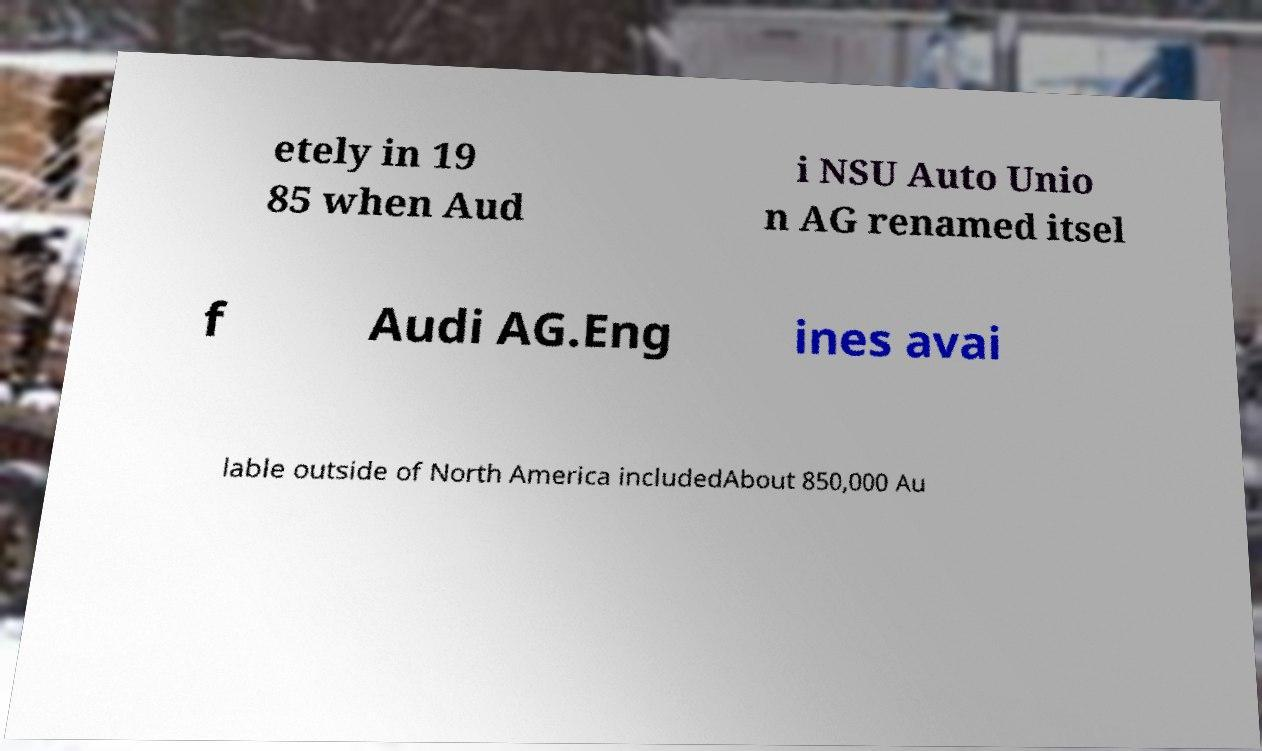I need the written content from this picture converted into text. Can you do that? etely in 19 85 when Aud i NSU Auto Unio n AG renamed itsel f Audi AG.Eng ines avai lable outside of North America includedAbout 850,000 Au 